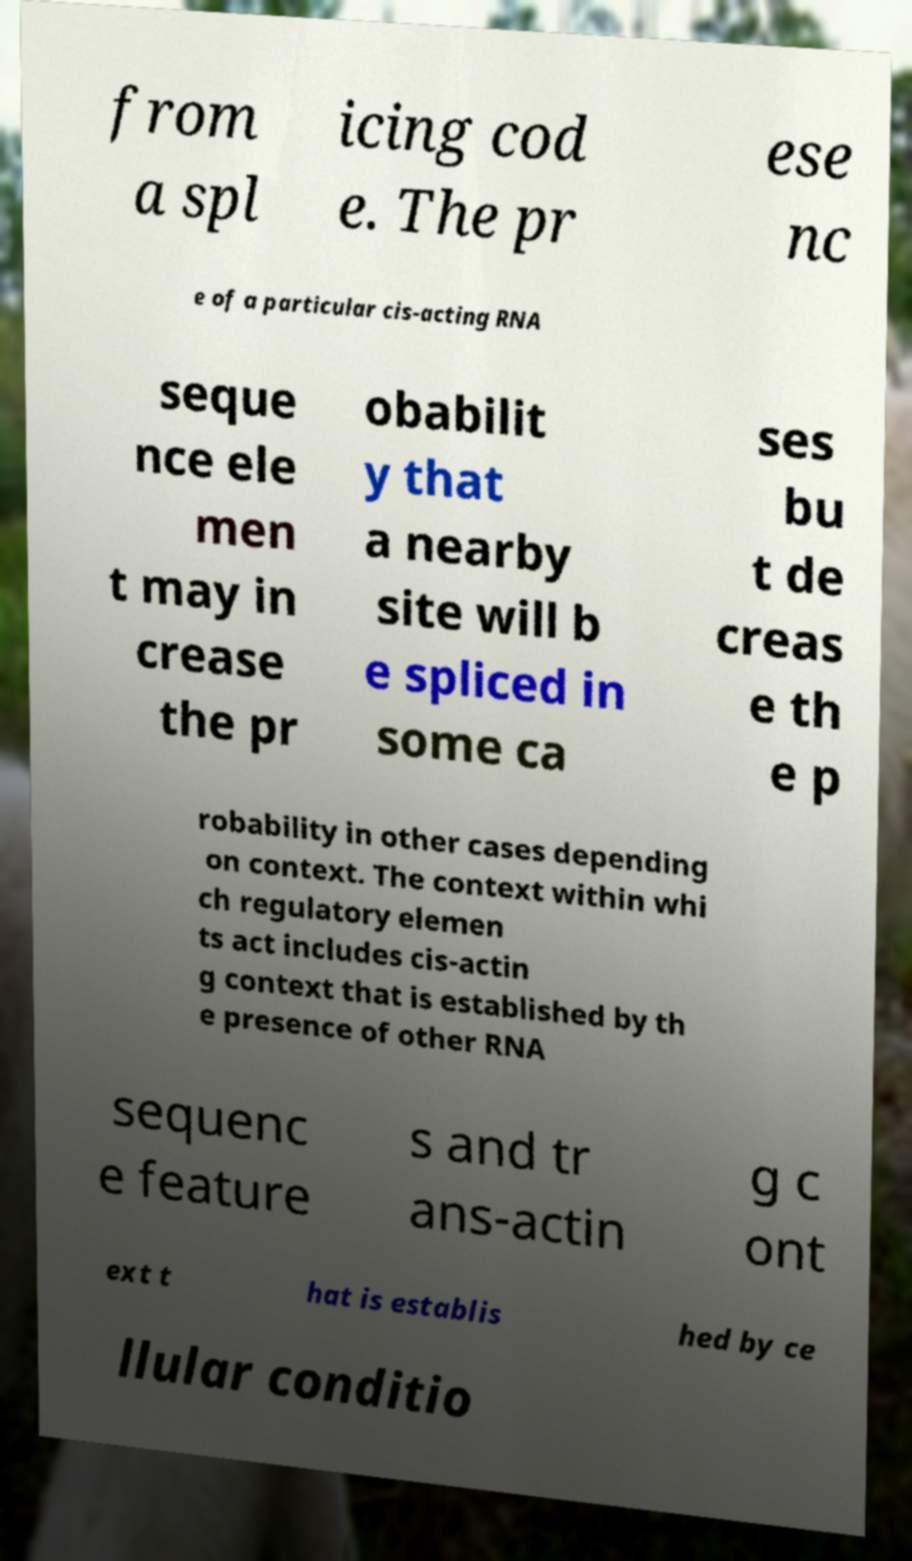Could you extract and type out the text from this image? from a spl icing cod e. The pr ese nc e of a particular cis-acting RNA seque nce ele men t may in crease the pr obabilit y that a nearby site will b e spliced in some ca ses bu t de creas e th e p robability in other cases depending on context. The context within whi ch regulatory elemen ts act includes cis-actin g context that is established by th e presence of other RNA sequenc e feature s and tr ans-actin g c ont ext t hat is establis hed by ce llular conditio 